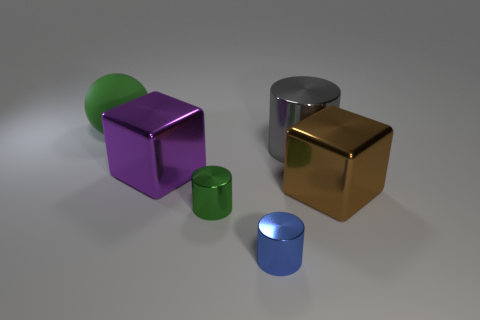Subtract all green cylinders. How many cylinders are left? 2 Subtract all green cylinders. How many cylinders are left? 2 Add 1 brown cubes. How many objects exist? 7 Subtract 2 blocks. How many blocks are left? 0 Subtract all blocks. How many objects are left? 4 Subtract all brown spheres. Subtract all gray blocks. How many spheres are left? 1 Subtract all cyan cubes. How many gray balls are left? 0 Subtract all blue shiny cylinders. Subtract all green cylinders. How many objects are left? 4 Add 2 large blocks. How many large blocks are left? 4 Add 1 big yellow shiny spheres. How many big yellow shiny spheres exist? 1 